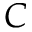<formula> <loc_0><loc_0><loc_500><loc_500>C</formula> 